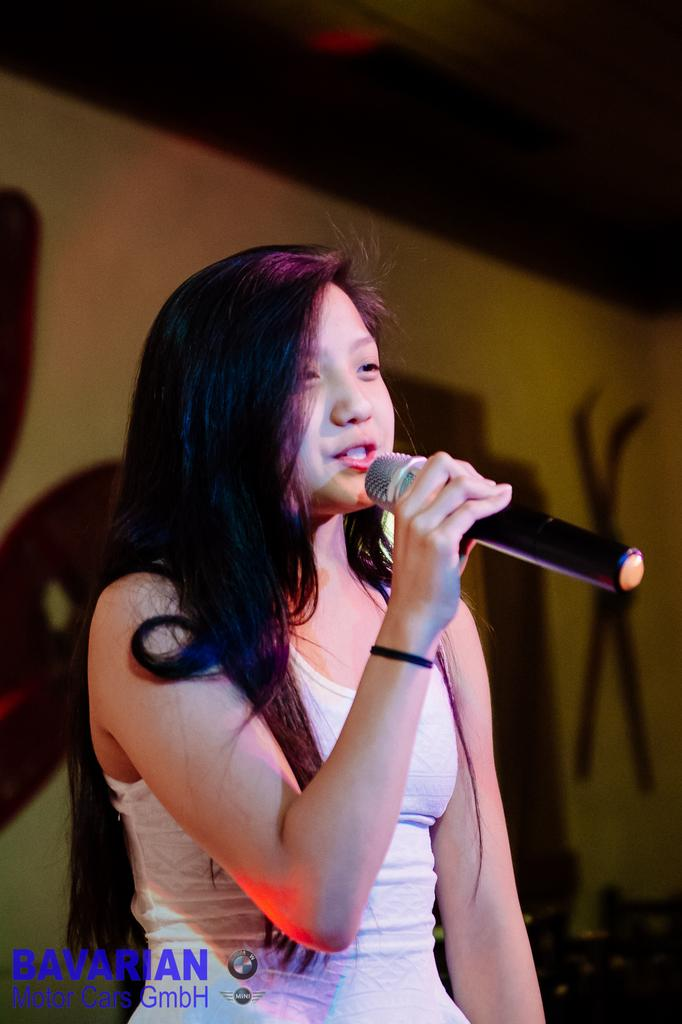Who is the main subject in the image? There is a woman in the image. What is the woman wearing? The woman is wearing a white dress. What is the woman doing in the image? The woman is singing. What object is present in the image that is related to the woman's activity? There is a microphone in the image. What type of jelly is being used as a prop in the image? There is no jelly present in the image. What attraction is the woman performing at in the image? The image does not provide information about the location or event where the woman is singing. 